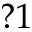Convert formula to latex. <formula><loc_0><loc_0><loc_500><loc_500>? 1</formula> 